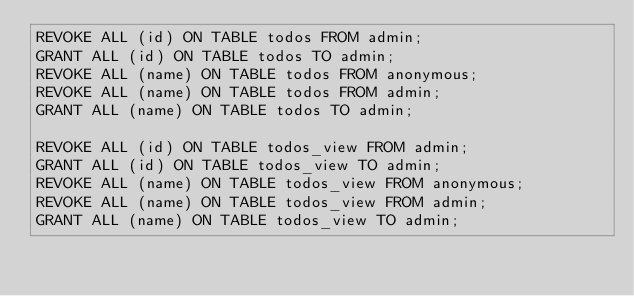<code> <loc_0><loc_0><loc_500><loc_500><_SQL_>REVOKE ALL (id) ON TABLE todos FROM admin;
GRANT ALL (id) ON TABLE todos TO admin;
REVOKE ALL (name) ON TABLE todos FROM anonymous;
REVOKE ALL (name) ON TABLE todos FROM admin;
GRANT ALL (name) ON TABLE todos TO admin;

REVOKE ALL (id) ON TABLE todos_view FROM admin;
GRANT ALL (id) ON TABLE todos_view TO admin;
REVOKE ALL (name) ON TABLE todos_view FROM anonymous;
REVOKE ALL (name) ON TABLE todos_view FROM admin;
GRANT ALL (name) ON TABLE todos_view TO admin;
</code> 